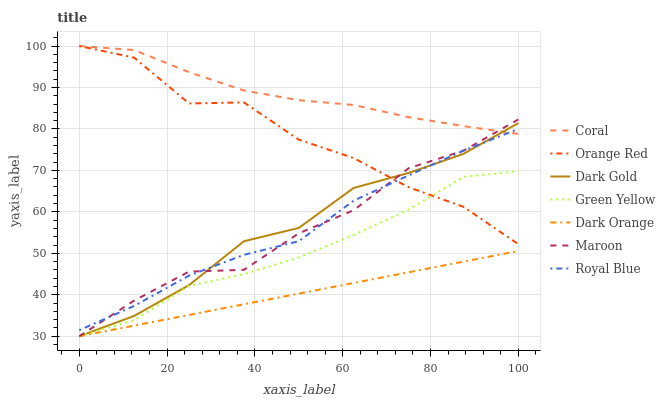Does Dark Orange have the minimum area under the curve?
Answer yes or no. Yes. Does Coral have the maximum area under the curve?
Answer yes or no. Yes. Does Dark Gold have the minimum area under the curve?
Answer yes or no. No. Does Dark Gold have the maximum area under the curve?
Answer yes or no. No. Is Dark Orange the smoothest?
Answer yes or no. Yes. Is Orange Red the roughest?
Answer yes or no. Yes. Is Dark Gold the smoothest?
Answer yes or no. No. Is Dark Gold the roughest?
Answer yes or no. No. Does Dark Orange have the lowest value?
Answer yes or no. Yes. Does Coral have the lowest value?
Answer yes or no. No. Does Orange Red have the highest value?
Answer yes or no. Yes. Does Dark Gold have the highest value?
Answer yes or no. No. Is Dark Orange less than Royal Blue?
Answer yes or no. Yes. Is Royal Blue greater than Green Yellow?
Answer yes or no. Yes. Does Dark Gold intersect Royal Blue?
Answer yes or no. Yes. Is Dark Gold less than Royal Blue?
Answer yes or no. No. Is Dark Gold greater than Royal Blue?
Answer yes or no. No. Does Dark Orange intersect Royal Blue?
Answer yes or no. No. 